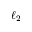Convert formula to latex. <formula><loc_0><loc_0><loc_500><loc_500>\ell _ { 2 }</formula> 